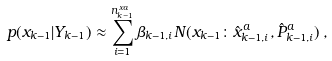Convert formula to latex. <formula><loc_0><loc_0><loc_500><loc_500>p ( x _ { k - 1 } | Y _ { k - 1 } ) \approx \sum _ { i = 1 } ^ { n _ { k - 1 } ^ { x a } } \beta _ { k - 1 , i } N ( x _ { k - 1 } \colon \hat { x } _ { k - 1 , i } ^ { a } , \hat { P } _ { k - 1 , i } ^ { a } ) \, ,</formula> 